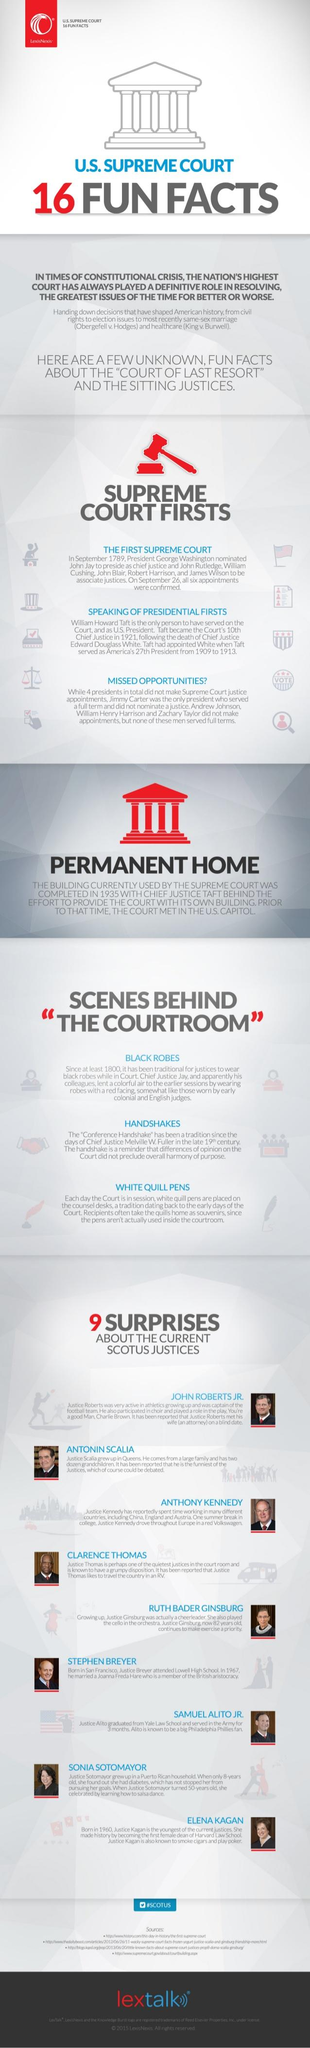Indicate a few pertinent items in this graphic. Ruth Bader Ginsburg enjoys exercising. Anthony Kennedy likes to drive a Volkswagen vehicle, and it is known that he is fond of this type of car. What are not actually used inside the courtroom? White quill pens. The color of the hammer is red. In 1921, President Taft replaced Chief Justice Edward Douglass White. 